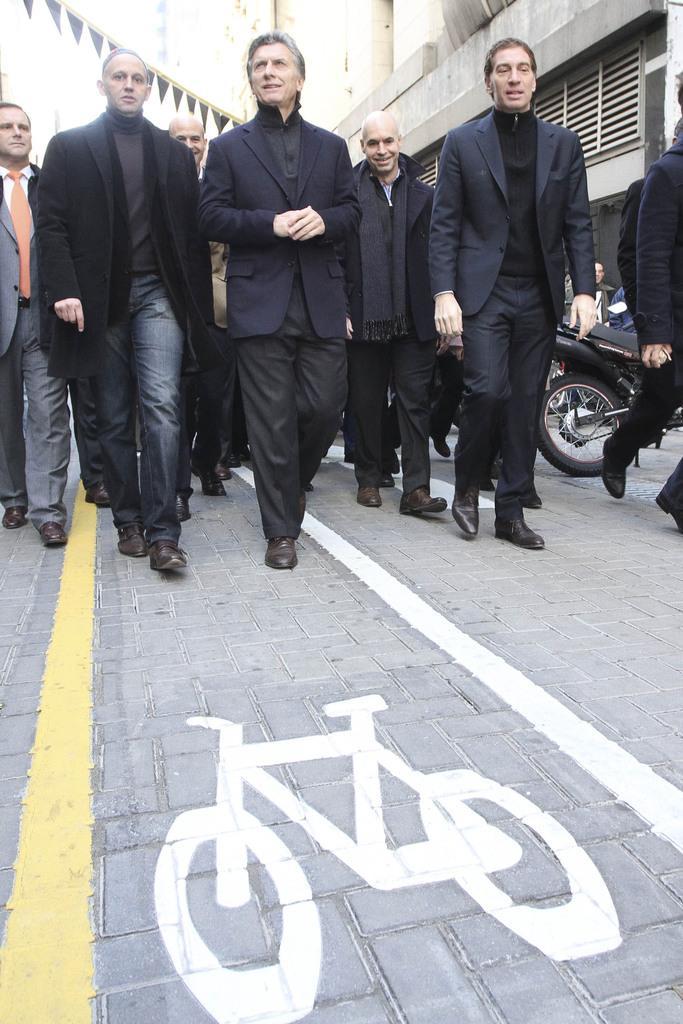Could you give a brief overview of what you see in this image? In this picture, there are group of people walking on the road. Most of the men are wearing blazers and trousers. Towards the right, there is a motorbike. On the top, there is a building. 